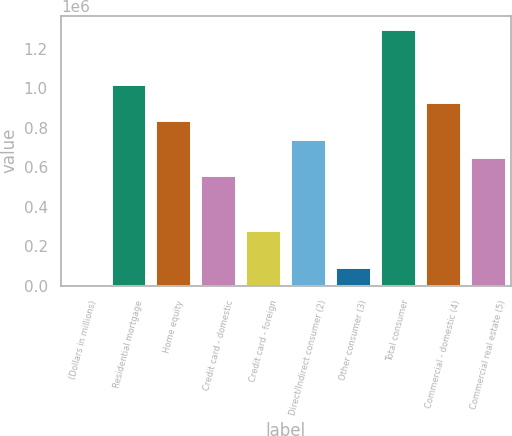Convert chart. <chart><loc_0><loc_0><loc_500><loc_500><bar_chart><fcel>(Dollars in millions)<fcel>Residential mortgage<fcel>Home equity<fcel>Credit card - domestic<fcel>Credit card - foreign<fcel>Direct/Indirect consumer (2)<fcel>Other consumer (3)<fcel>Total consumer<fcel>Commercial - domestic (4)<fcel>Commercial real estate (5)<nl><fcel>2008<fcel>1.02439e+06<fcel>838502<fcel>559671<fcel>280839<fcel>745558<fcel>94951.8<fcel>1.30322e+06<fcel>931446<fcel>652615<nl></chart> 